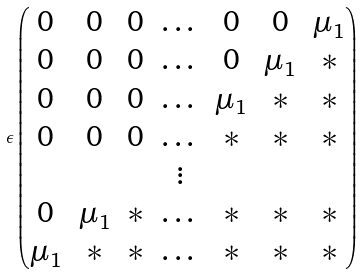Convert formula to latex. <formula><loc_0><loc_0><loc_500><loc_500>\epsilon \begin{pmatrix} 0 & 0 & 0 & \dots & 0 & 0 & \mu _ { 1 } \\ 0 & 0 & 0 & \dots & 0 & \mu _ { 1 } & * \\ 0 & 0 & 0 & \dots & \mu _ { 1 } & * & * \\ 0 & 0 & 0 & \dots & * & * & * \\ & & & \vdots \\ 0 & \mu _ { 1 } & * & \dots & * & * & * \\ \mu _ { 1 } & * & * & \dots & * & * & * \end{pmatrix}</formula> 